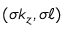Convert formula to latex. <formula><loc_0><loc_0><loc_500><loc_500>( \sigma k _ { z } , \sigma \ell )</formula> 